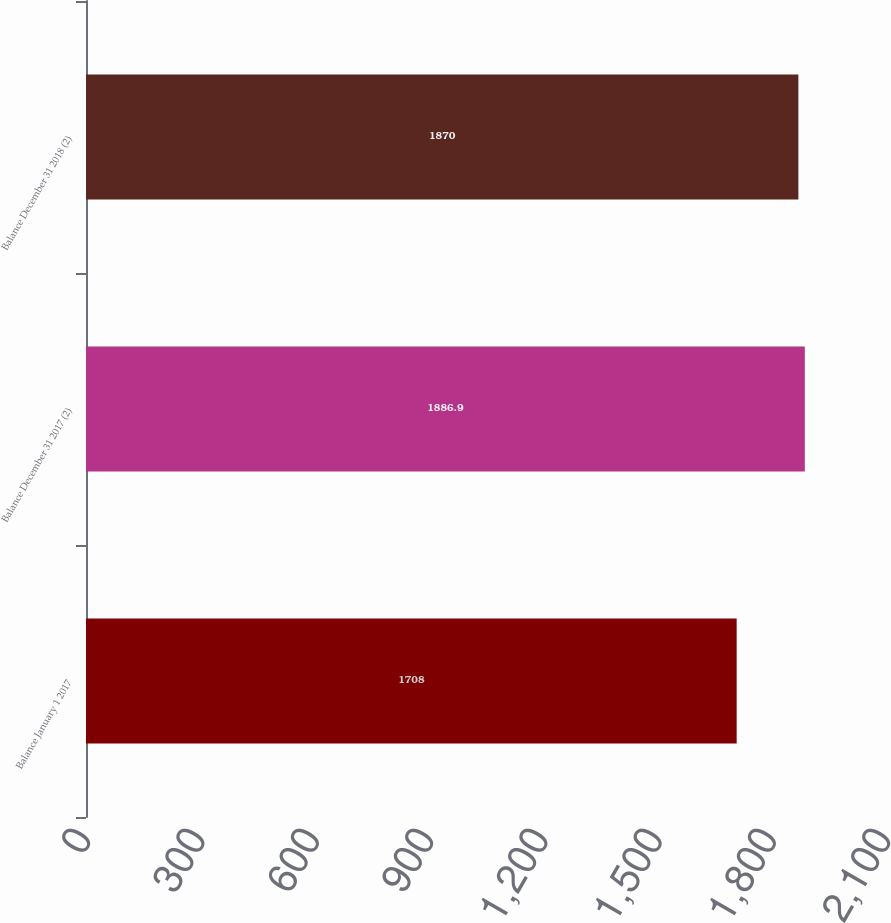Convert chart to OTSL. <chart><loc_0><loc_0><loc_500><loc_500><bar_chart><fcel>Balance January 1 2017<fcel>Balance December 31 2017 (2)<fcel>Balance December 31 2018 (2)<nl><fcel>1708<fcel>1886.9<fcel>1870<nl></chart> 